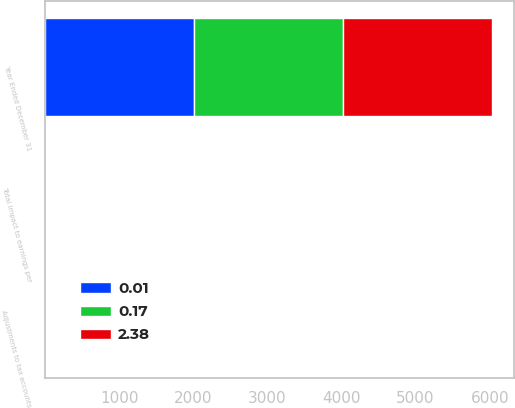<chart> <loc_0><loc_0><loc_500><loc_500><stacked_bar_chart><ecel><fcel>Year Ended December 31<fcel>Adjustments to tax accounts<fcel>Total impact to earnings per<nl><fcel>0.17<fcel>2009<fcel>0.03<fcel>0.17<nl><fcel>2.38<fcel>2008<fcel>0.02<fcel>2.38<nl><fcel>0.01<fcel>2007<fcel>0.03<fcel>0.01<nl></chart> 